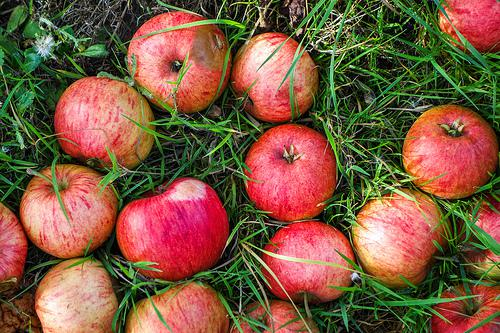Question: how many kinds of fruit?
Choices:
A. Two.
B. One.
C. Three.
D. Four.
Answer with the letter. Answer: B Question: what is red?
Choices:
A. Pepper.
B. Apple.
C. Potato.
D. Ketchup.
Answer with the letter. Answer: B Question: where are the apples?
Choices:
A. On the tree.
B. In a bowl.
C. Ground.
D. In a bag.
Answer with the letter. Answer: C Question: what is green?
Choices:
A. Leaves.
B. Bush.
C. Plant.
D. Grass.
Answer with the letter. Answer: D Question: when was the picture taken?
Choices:
A. Night time.
B. Morning.
C. Evening.
D. Daytime.
Answer with the letter. Answer: D 